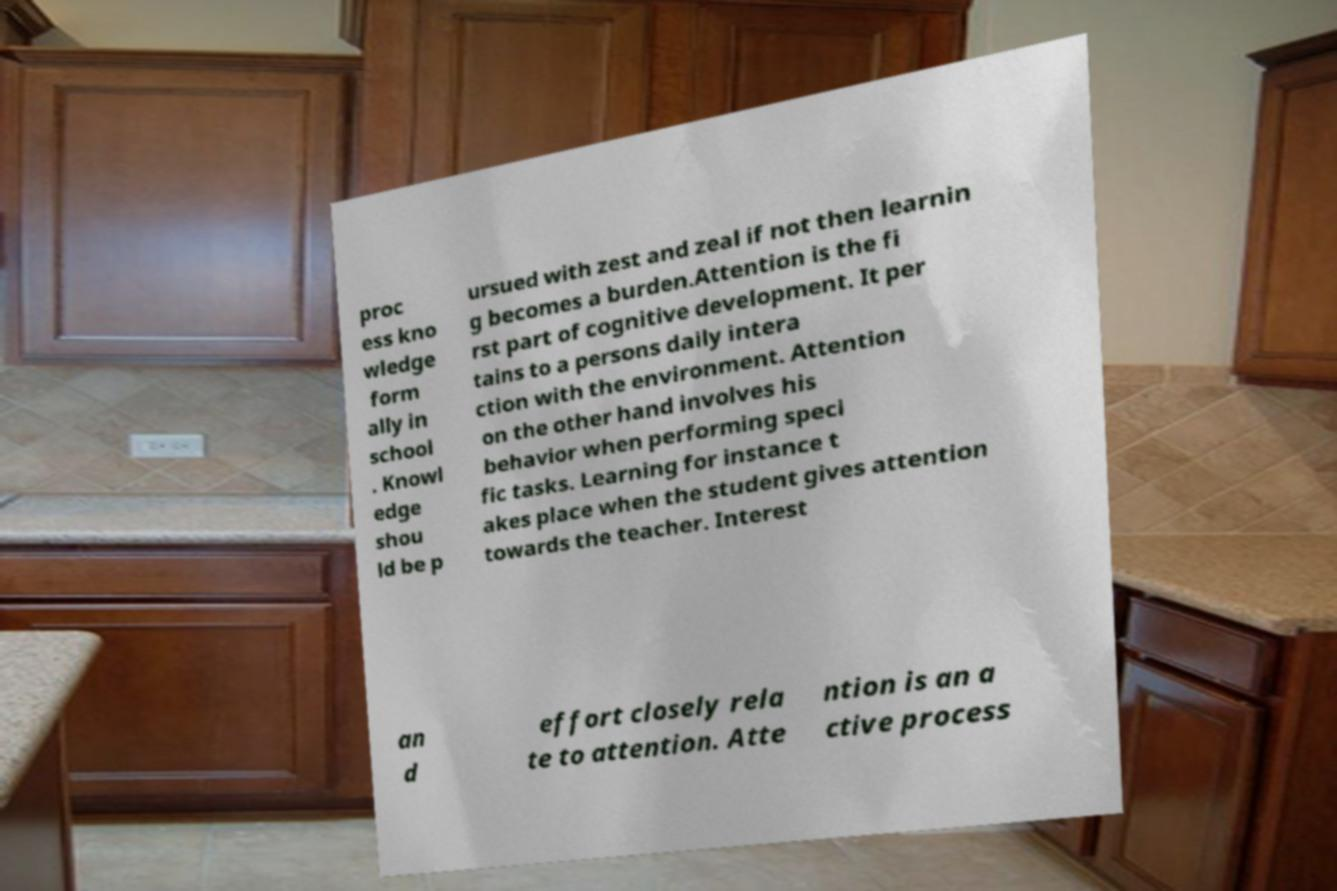For documentation purposes, I need the text within this image transcribed. Could you provide that? proc ess kno wledge form ally in school . Knowl edge shou ld be p ursued with zest and zeal if not then learnin g becomes a burden.Attention is the fi rst part of cognitive development. It per tains to a persons daily intera ction with the environment. Attention on the other hand involves his behavior when performing speci fic tasks. Learning for instance t akes place when the student gives attention towards the teacher. Interest an d effort closely rela te to attention. Atte ntion is an a ctive process 